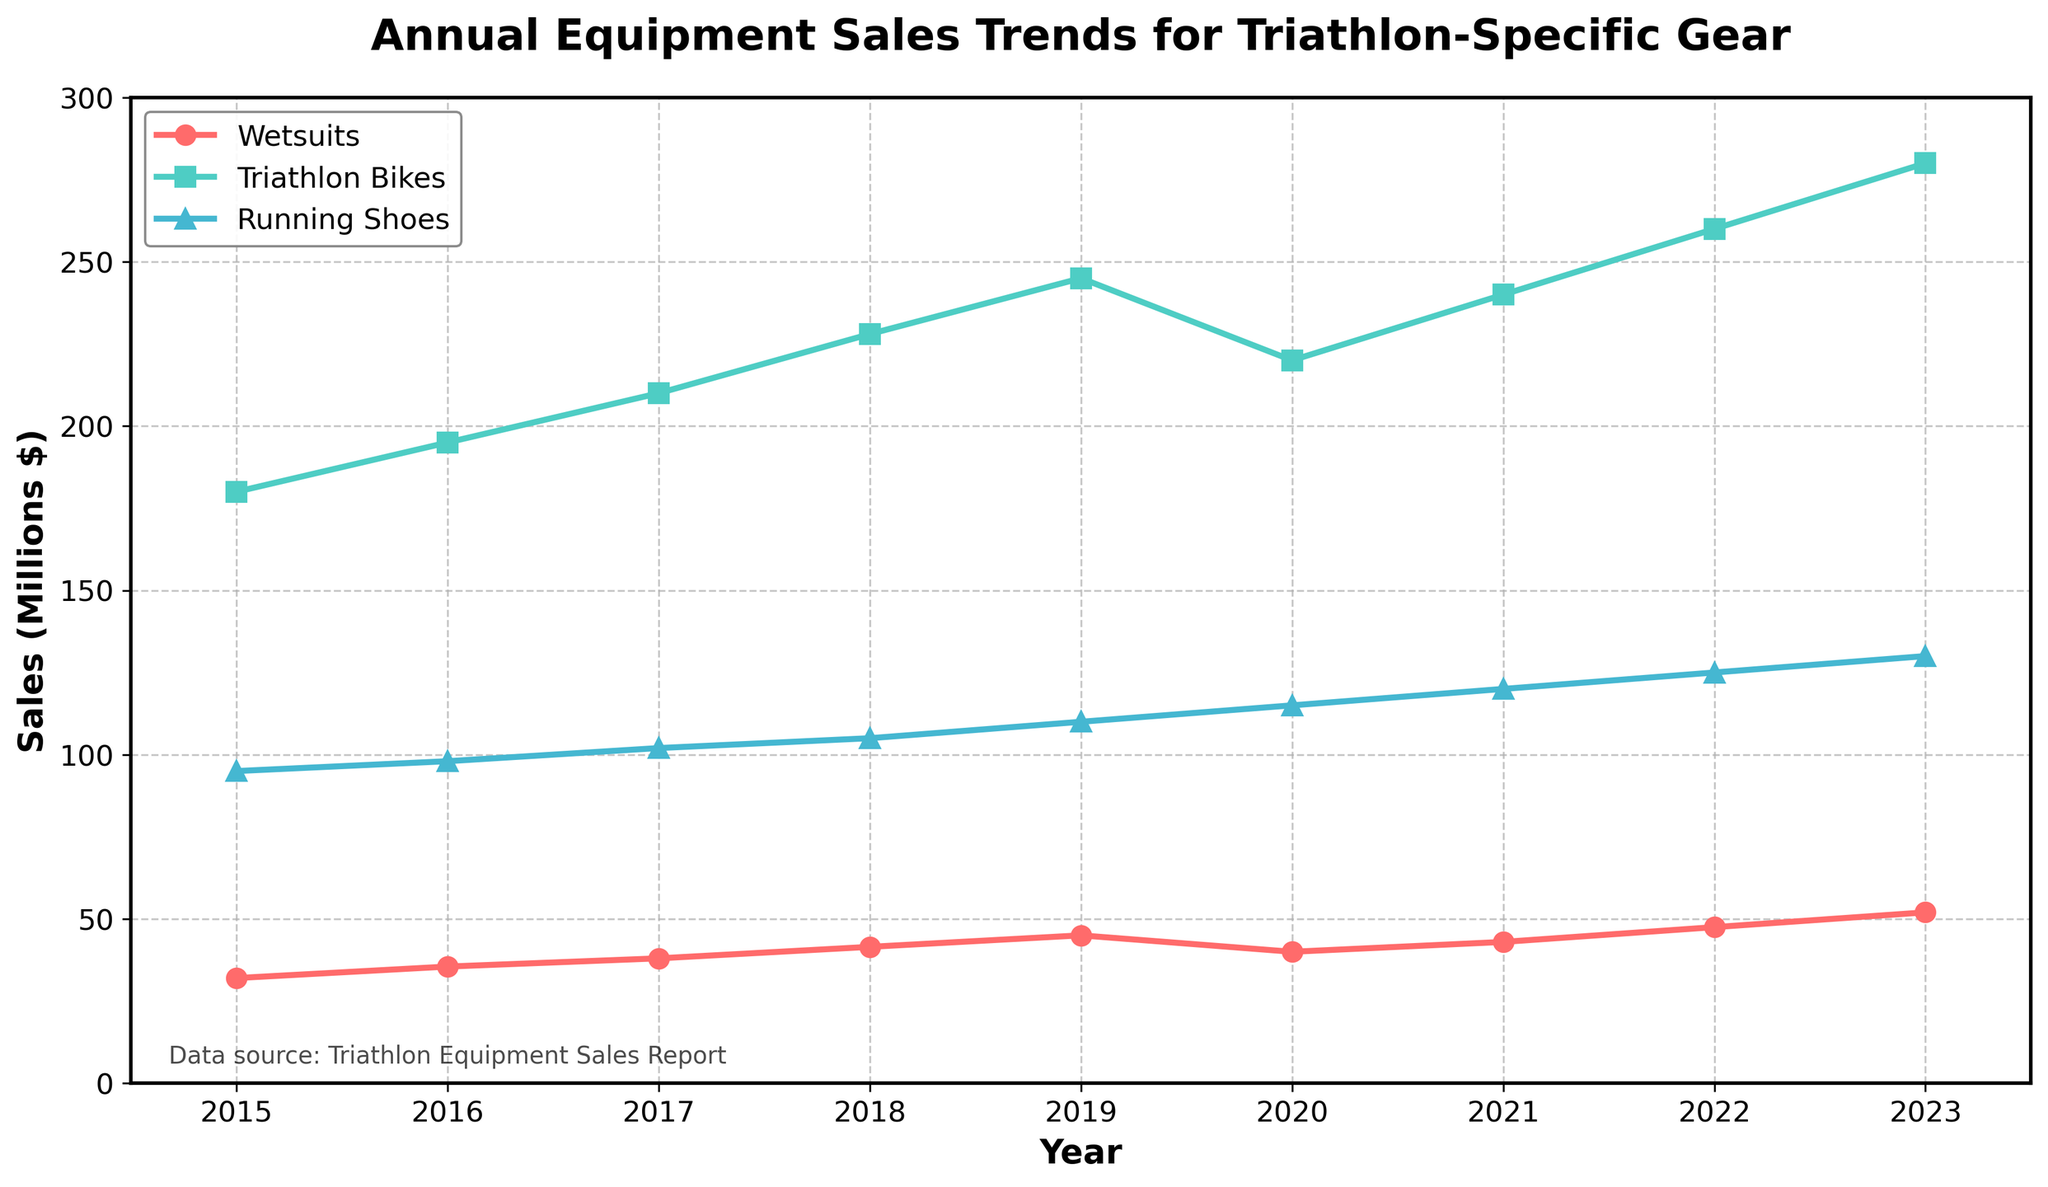What's the trend for wetsuit sales from 2015 to 2023? The wetsuit sales show a general increasing trend from 2015 to 2023, with a slight dip in 2020, and then continue rising.
Answer: Increasing, with a dip in 2020 Which category experienced the highest sales in 2023? By looking at the last year in the chart (2023), Triathlon Bikes have the highest sales compared to Wetsuits and Running Shoes.
Answer: Triathlon Bikes How much did running shoe sales increase from 2015 to 2023? Running shoe sales increased from $95 million in 2015 to $130 million in 2023. The increase is $130 million - $95 million.
Answer: $35 million In which year did wetsuit sales decline, and by how much compared to the previous year? The wetsuit sales declined in 2020. They dropped from $45 million in 2019 to $40 million in 2020, which is a decrease of $5 million.
Answer: 2020, $5 million Compare the sales trends of Triathlon Bikes and Running Shoes between 2020 and 2023. Between 2020 and 2023, Triathlon Bikes sales increased from $220 million to $280 million, while Running Shoes sales increased from $115 million to $130 million. Both categories show an upward trend but Triathlon Bikes increased more in absolute terms.
Answer: Both increased, Triathlon Bikes more Which category had the smallest increase in sales from 2015 to 2023? By calculating the difference for each category, Wetsuits increased by $20 million ($52 million - $32 million), Triathlon Bikes increased by $100 million ($280 million - $180 million), and Running Shoes increased by $35 million ($130 million - $95 million). The smallest increase is in Wetsuit sales.
Answer: Wetsuits What is the overall increase in triathlon-specific equipment sales from 2015 to 2023 for all categories combined? Summing up the increases: Wetsuits ($32 million to $52 million), Triathlon Bikes ($180 million to $280 million), and Running Shoes ($95 million to $130 million), we get ($20 million + $100 million + $35 million).
Answer: $155 million What year did the sales of Triathlon Bikes surpass $200 million? The sales of Triathlon Bikes surpassed $200 million in 2017, as sales reached $210 million that year.
Answer: 2017 Which year had the largest combined sales for all three categories? Combined sales are highest in 2023. Adding up the sales for each category, we get Wetsuits ($52 million) + Triathlon Bikes ($280 million) + Running Shoes ($130 million).
Answer: 2023 What visual elements indicate the dip and subsequent recovery in Wetsuit sales? The plot shows a visible dip in the line representing Wetsuits around the year 2020 and then an upward trend in the subsequent years, resuming the increasing trend.
Answer: Dip in 2020, recovery afterward 